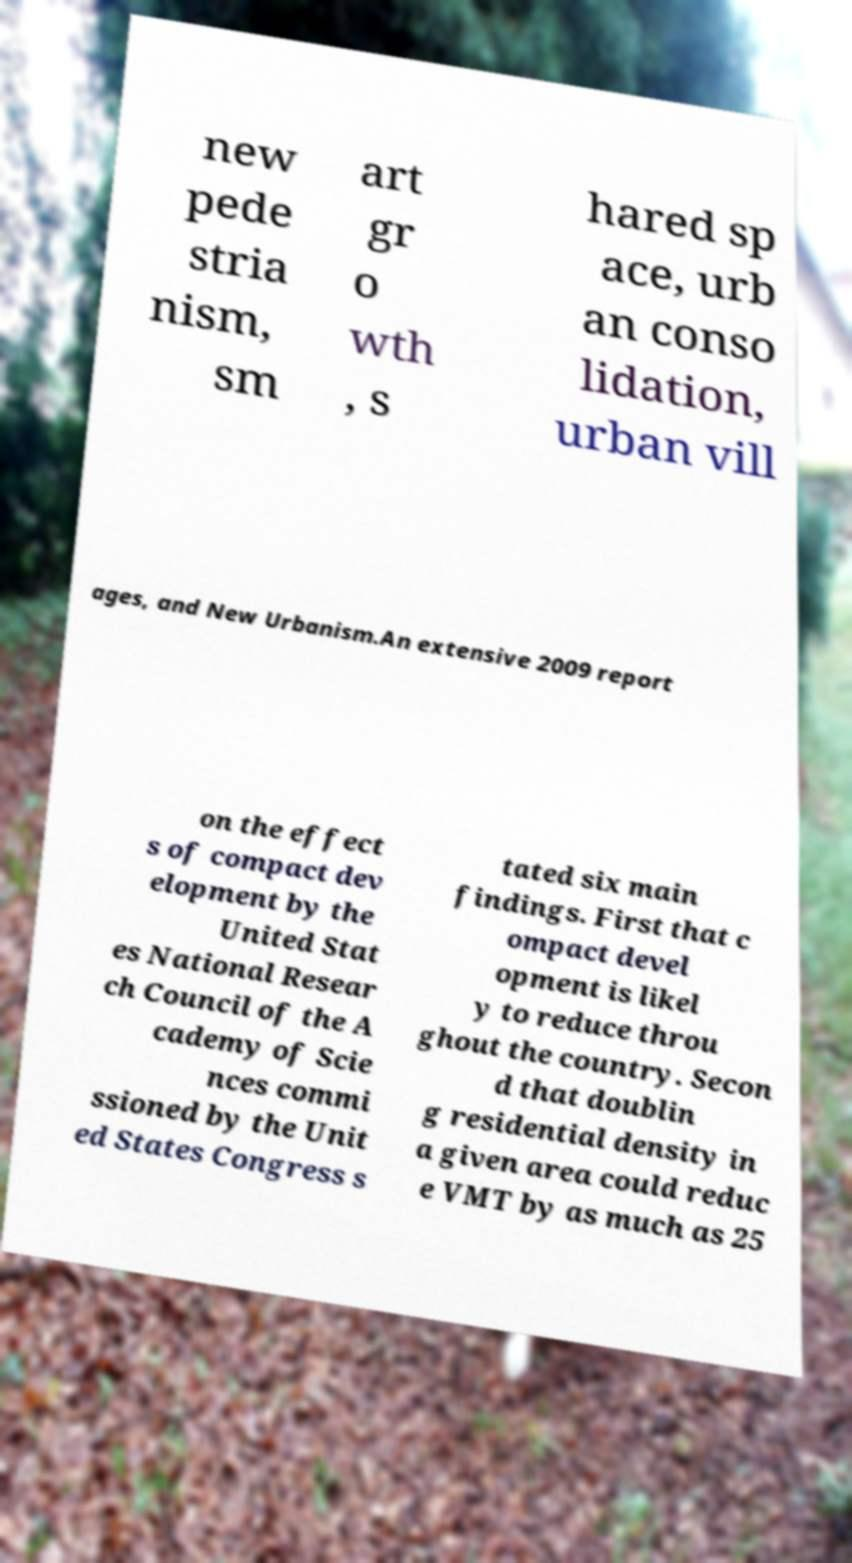Can you read and provide the text displayed in the image?This photo seems to have some interesting text. Can you extract and type it out for me? new pede stria nism, sm art gr o wth , s hared sp ace, urb an conso lidation, urban vill ages, and New Urbanism.An extensive 2009 report on the effect s of compact dev elopment by the United Stat es National Resear ch Council of the A cademy of Scie nces commi ssioned by the Unit ed States Congress s tated six main findings. First that c ompact devel opment is likel y to reduce throu ghout the country. Secon d that doublin g residential density in a given area could reduc e VMT by as much as 25 